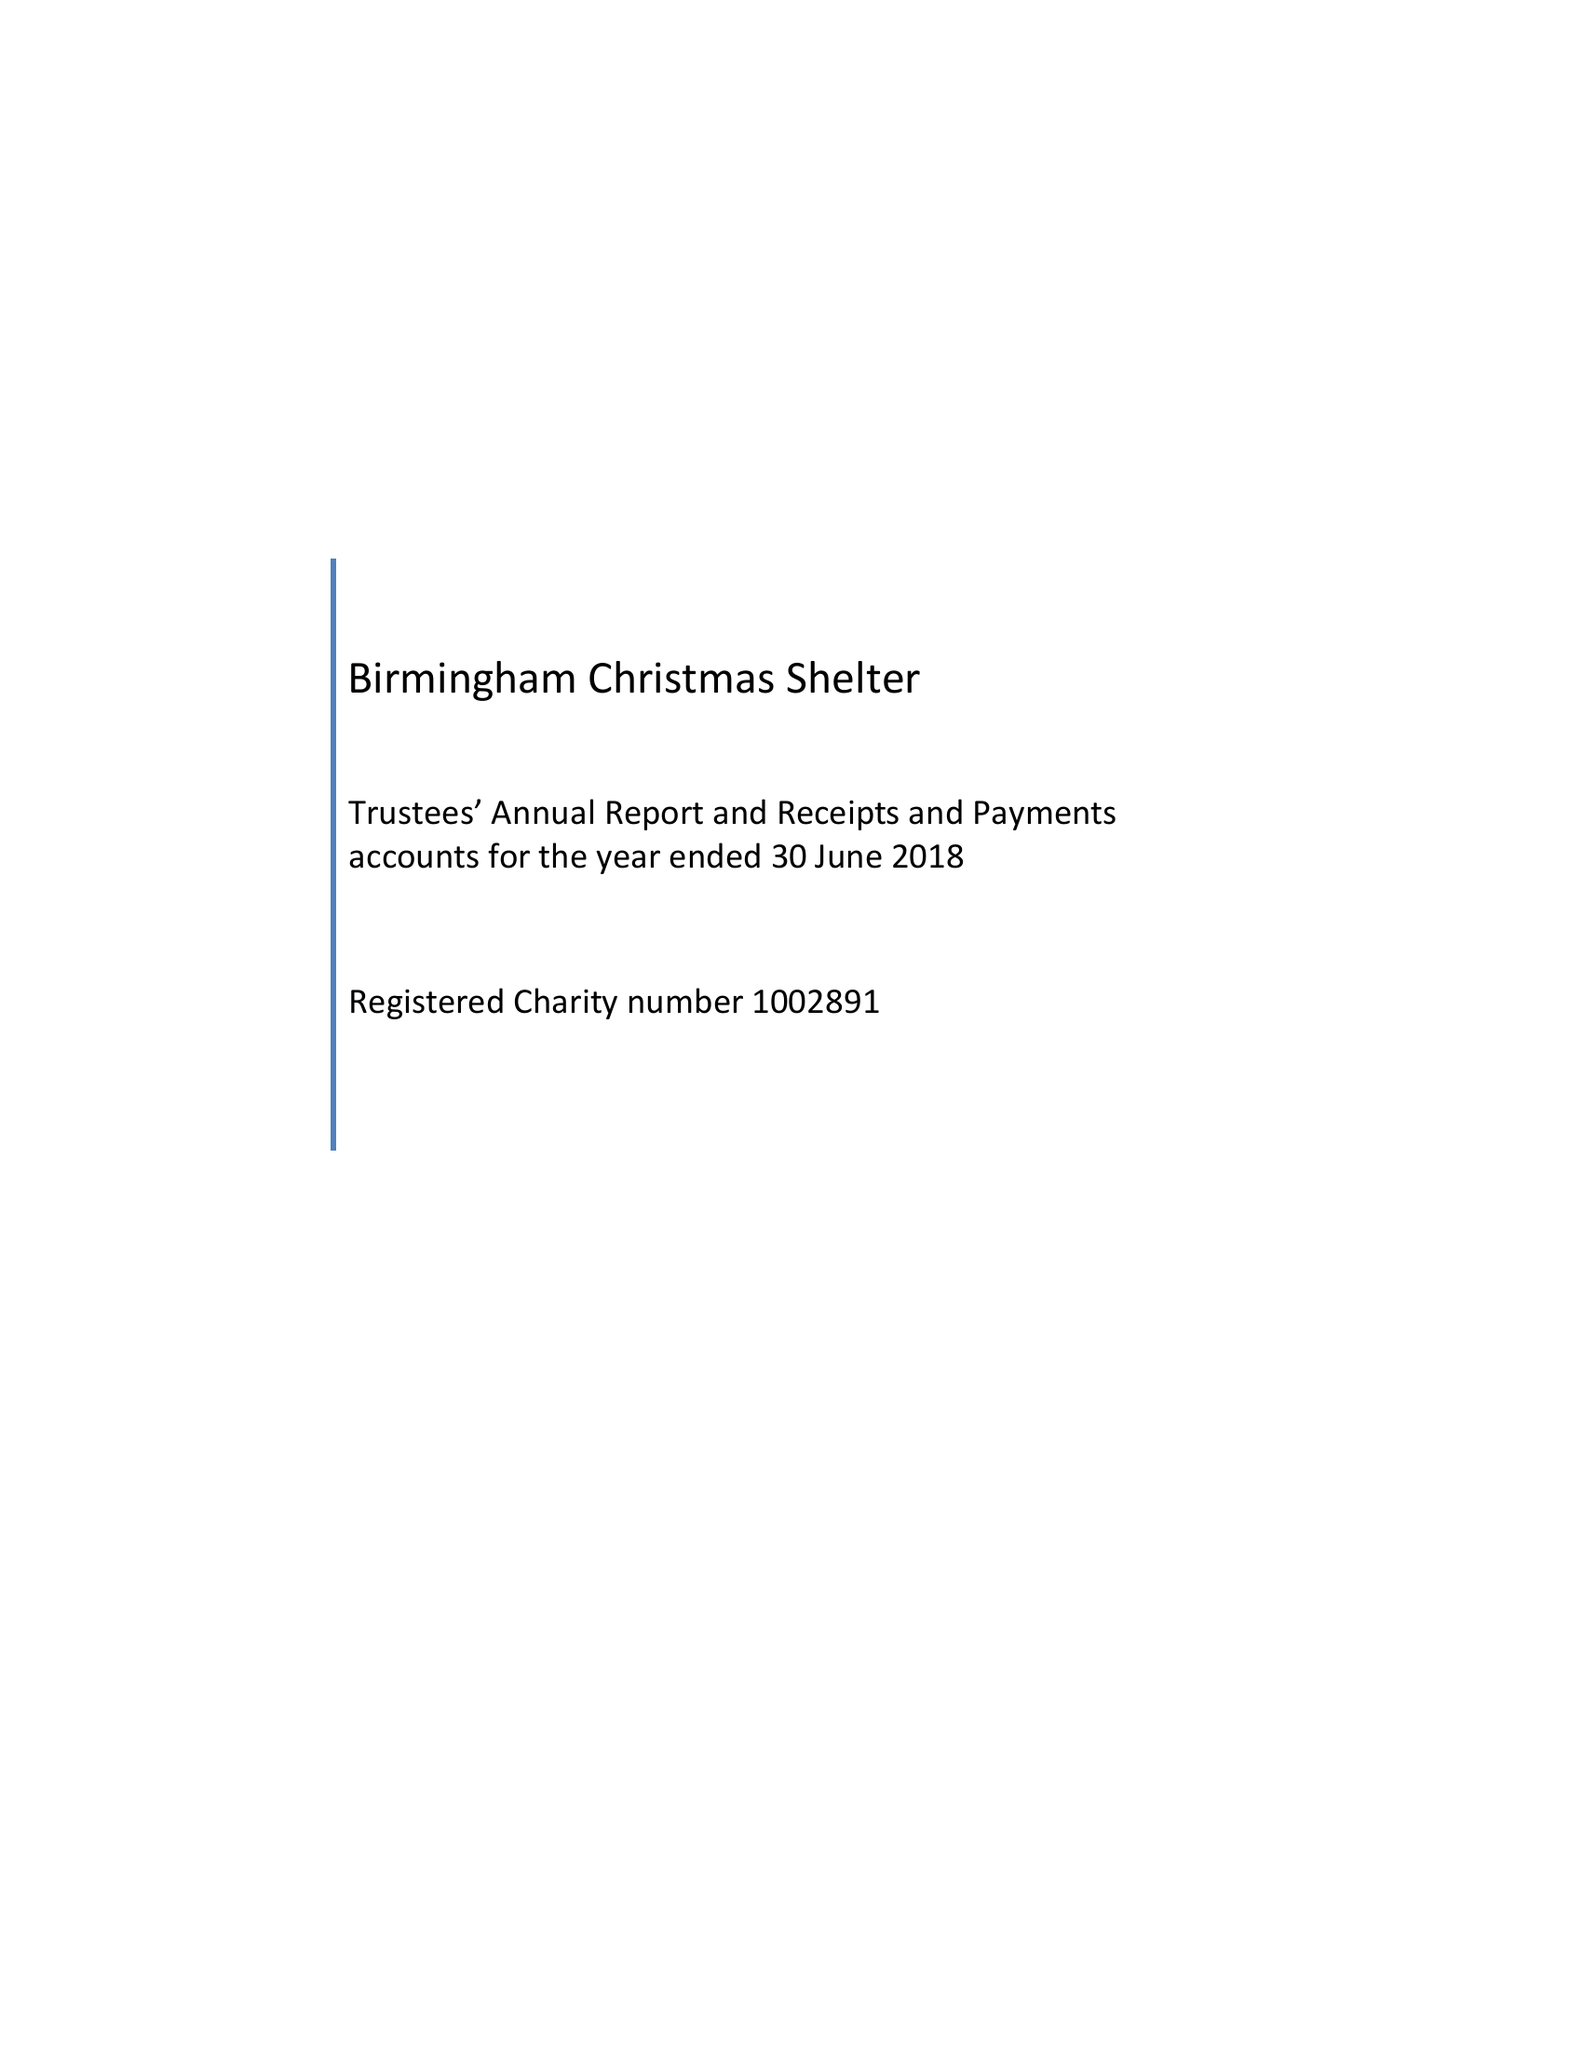What is the value for the address__post_town?
Answer the question using a single word or phrase. BIRMINGHAM 